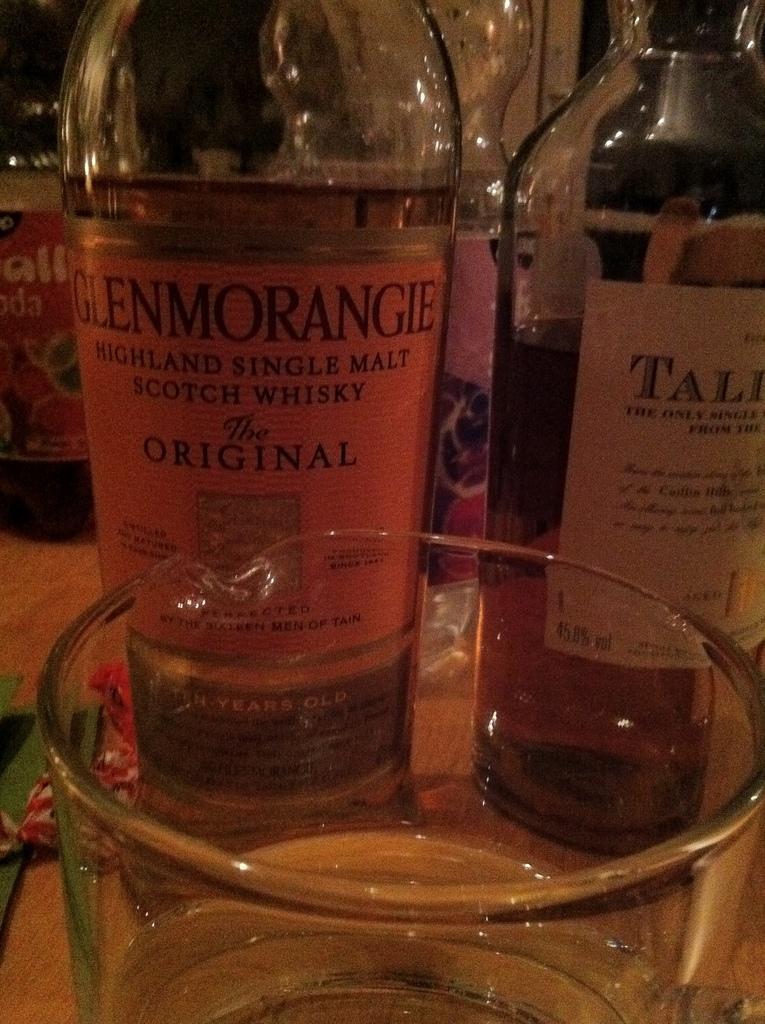Could you give a brief overview of what you see in this image? In this image there are bottles with different labels and there is a glass. 